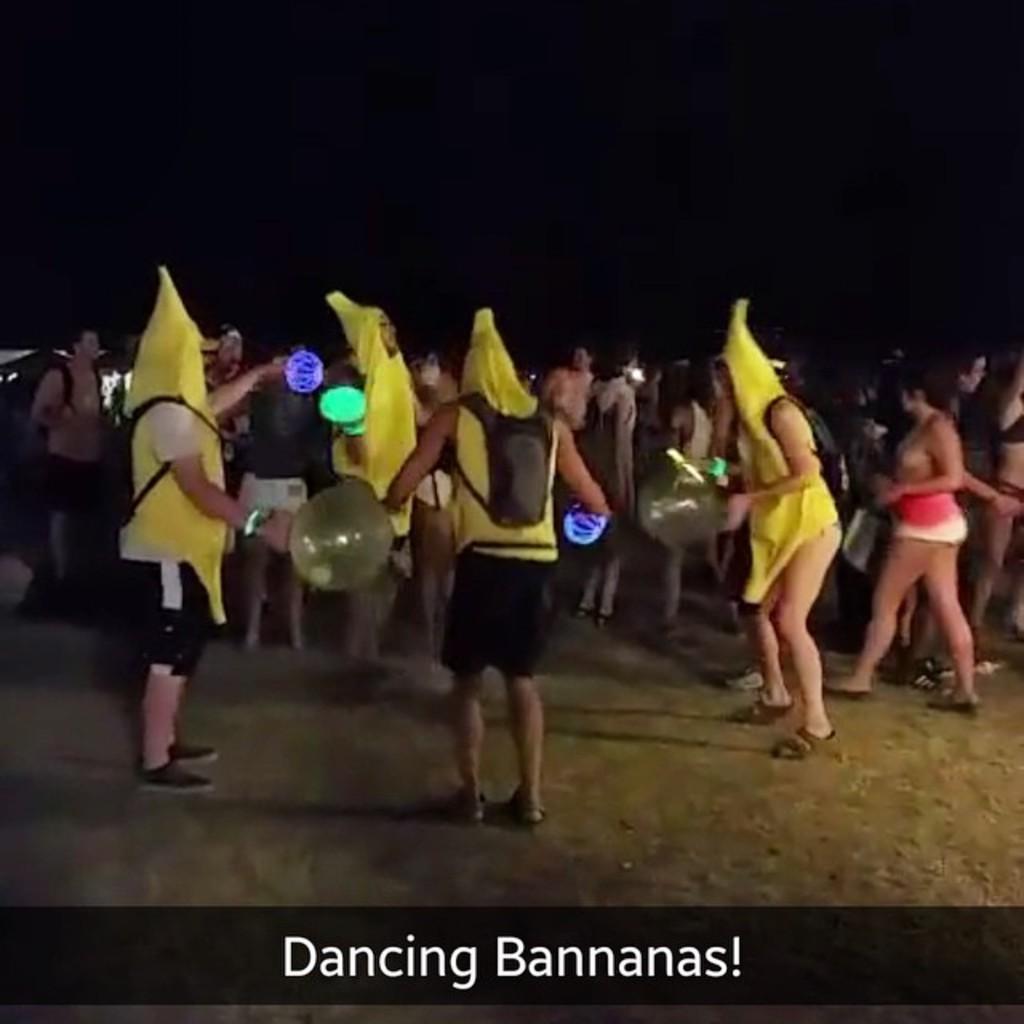In one or two sentences, can you explain what this image depicts? There are many people. Some are wearing yellow color dresses and bags. Also some are holding balloons and lights. On the down of the image there is something written on the black background. 